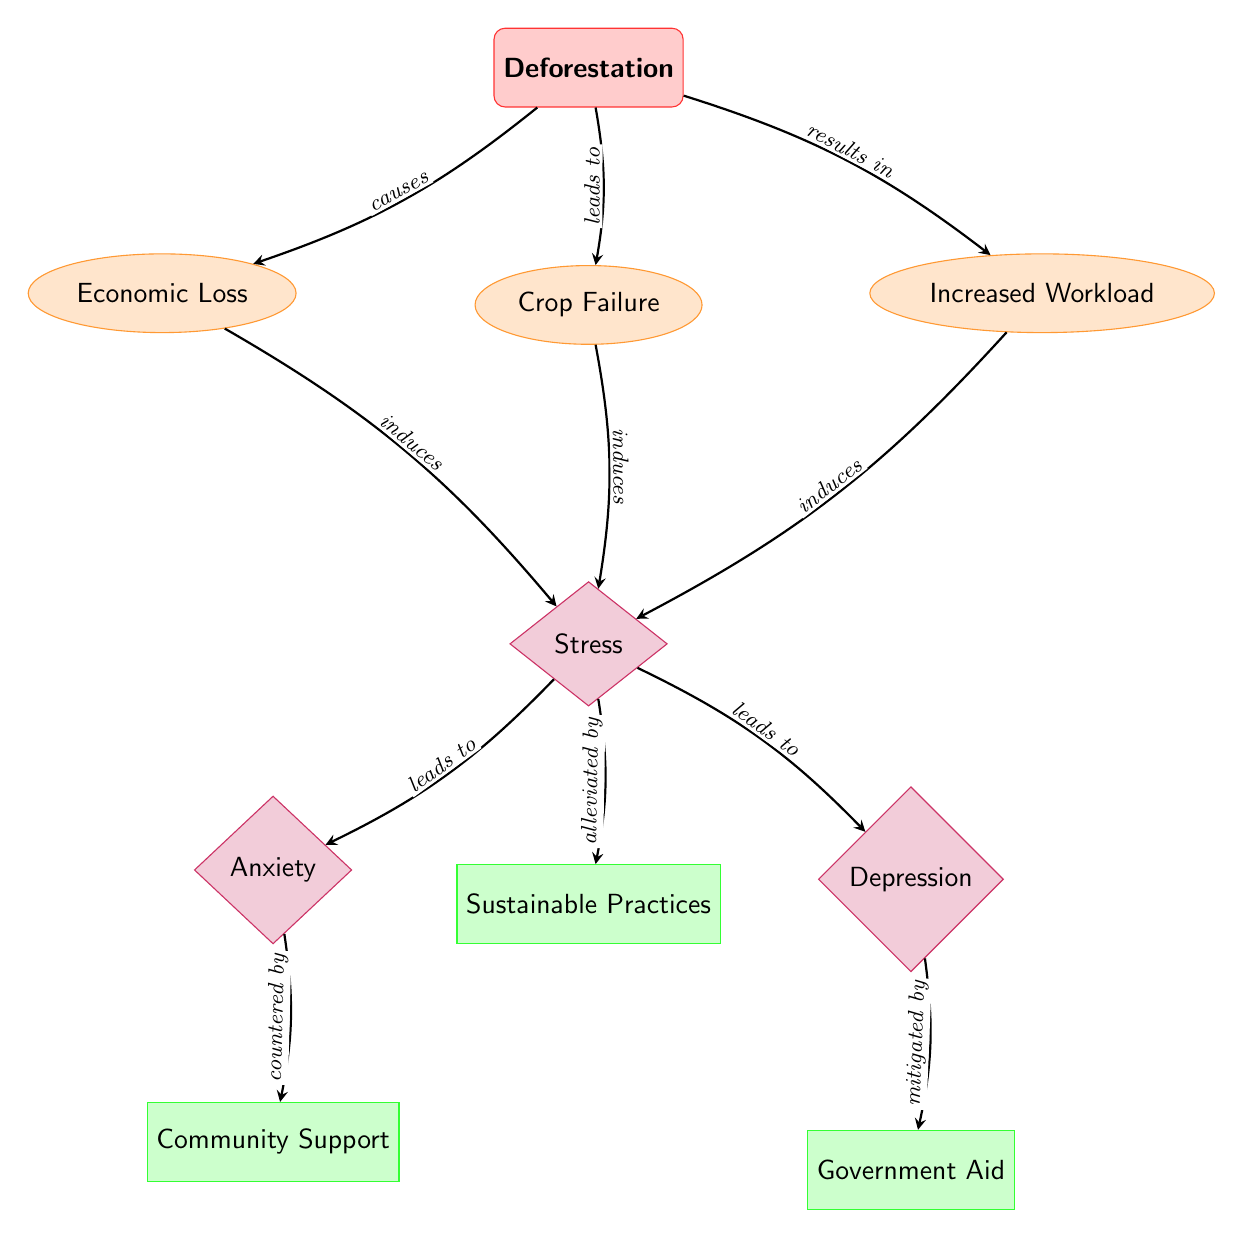What are the three stress indicators linked to deforestation? The diagram lists three stress indicators connected to deforestation: Economic Loss, Crop Failure, and Increased Workload. These are derived directly from the nodes positioned below the 'Deforestation' trigger.
Answer: Economic Loss, Crop Failure, Increased Workload Which mental health impact is induced by workload increase? The diagram shows that the Increased Workload stress indicator leads to the mental health impact labeled 'Stress.' Therefore, the mental health impact induced by the workload increase is stress.
Answer: Stress How many coping mechanisms are mentioned in the diagram? The diagram lists three coping mechanisms: Community Support, Government Aid, and Sustainable Practices. Counting the nodes labeled as coping mechanisms gives the total.
Answer: 3 What does anxiety countered by according to the diagram? In the diagram, the edge from the 'Anxiety' mental health impact node points to the 'Community Support' coping mechanism node, indicating that anxiety is countered by community support.
Answer: Community Support Which mental health impact is mitigated by government aid? The diagram illustrates that the 'Depression' mental health impact is specifically mentioned as being mitigated by the 'Government Aid' coping mechanism, as indicated by the arrow connecting them.
Answer: Depression What causes economic loss according to the diagram? The diagram indicates that 'Deforestation' causes the stress indicator 'Economic Loss' directly, as shown by the labeled edge connecting these two nodes.
Answer: Deforestation Which coping mechanism alleviates stress? The diagram indicates that the coping mechanism 'Sustainable Practices' is specifically labeled as alleviating 'Stress,' which connects the two nodes.
Answer: Sustainable Practices How many edges are in this diagram? By counting each connection drawn from one node to another, the diagram contains eight edges, showing the relationships between different components.
Answer: 8 What induces anxiety in the diagram? According to the diagram, 'Stress' leads to 'Anxiety,' as the arrow points from the 'Stress' node to the 'Anxiety' node, indicating that anxiety is induced by stress.
Answer: Stress 